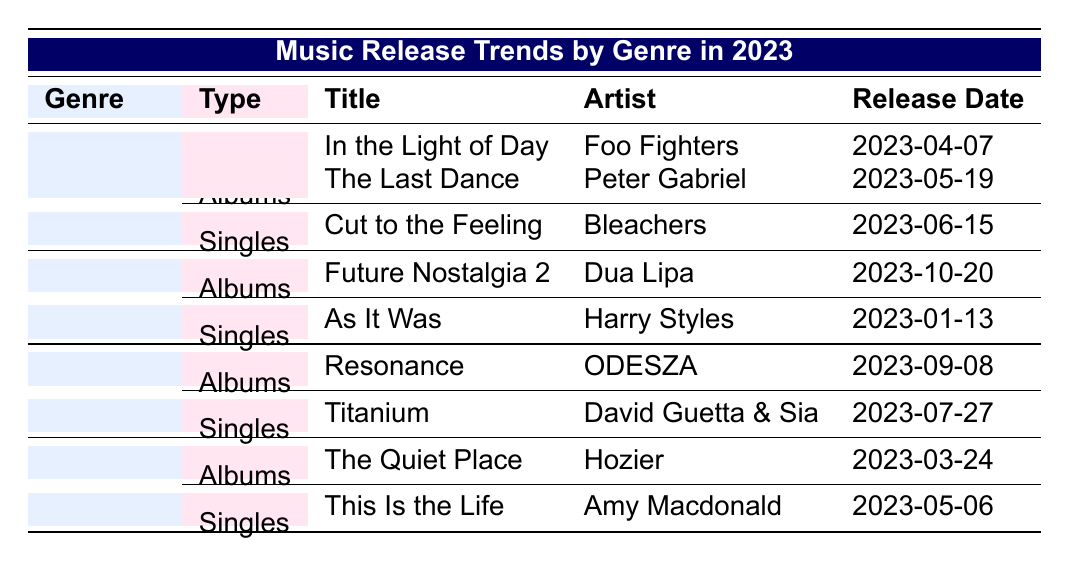What is the title of the album released by Peter Gabriel in 2023? The table indicates that the album titled "The Last Dance" was released by Peter Gabriel. It is specifically listed under the Albums section for the Rock genre.
Answer: The Last Dance How many singles were released in the Pop genre in 2023? The table shows one single under the Pop genre. The single listed is "As It Was" by Harry Styles.
Answer: 1 Which artist released an album called "Resonance" in 2023? According to the table, ODESZA is the artist who released the album "Resonance" under the Electronic genre.
Answer: ODESZA Are there any albums released in the Indie genre during 2023? The table confirms that there is one album under the Indie genre, titled "The Quiet Place," released by Hozier.
Answer: Yes What is the release date of the single "Titanium"? The table specifies that the single "Titanium" by David Guetta & Sia was released on July 27, 2023.
Answer: 2023-07-27 Which genre had the most album releases? By examining the table, Rock and Indie both have two albums listed, while Pop and Electronic have one each. Since Rock has the highest number of albums, it is the genre with the most releases.
Answer: Rock When did Dua Lipa release "Future Nostalgia 2"? The table indicates that "Future Nostalgia 2" was released on October 20, 2023, by Dua Lipa under the Pop genre.
Answer: 2023-10-20 Did any singles in 2023 come from the Rock genre? The table states that there is one single titled "Cut to the Feeling" under the Rock genre, confirming that at least one single was released.
Answer: Yes What is the difference in the number of albums released between the Rock and Pop genres? The table shows that Rock has two albums (including Peter Gabriel's) while Pop has one. Thus, the difference is calculated as 2 (Rock) - 1 (Pop) = 1.
Answer: 1 How many total music releases (albums and singles) were there in the Electronic genre? In the Electronic genre, there is one album ("Resonance") and one single ("Titanium"). Thus, the total number of releases is 1 (Album) + 1 (Single) = 2.
Answer: 2 